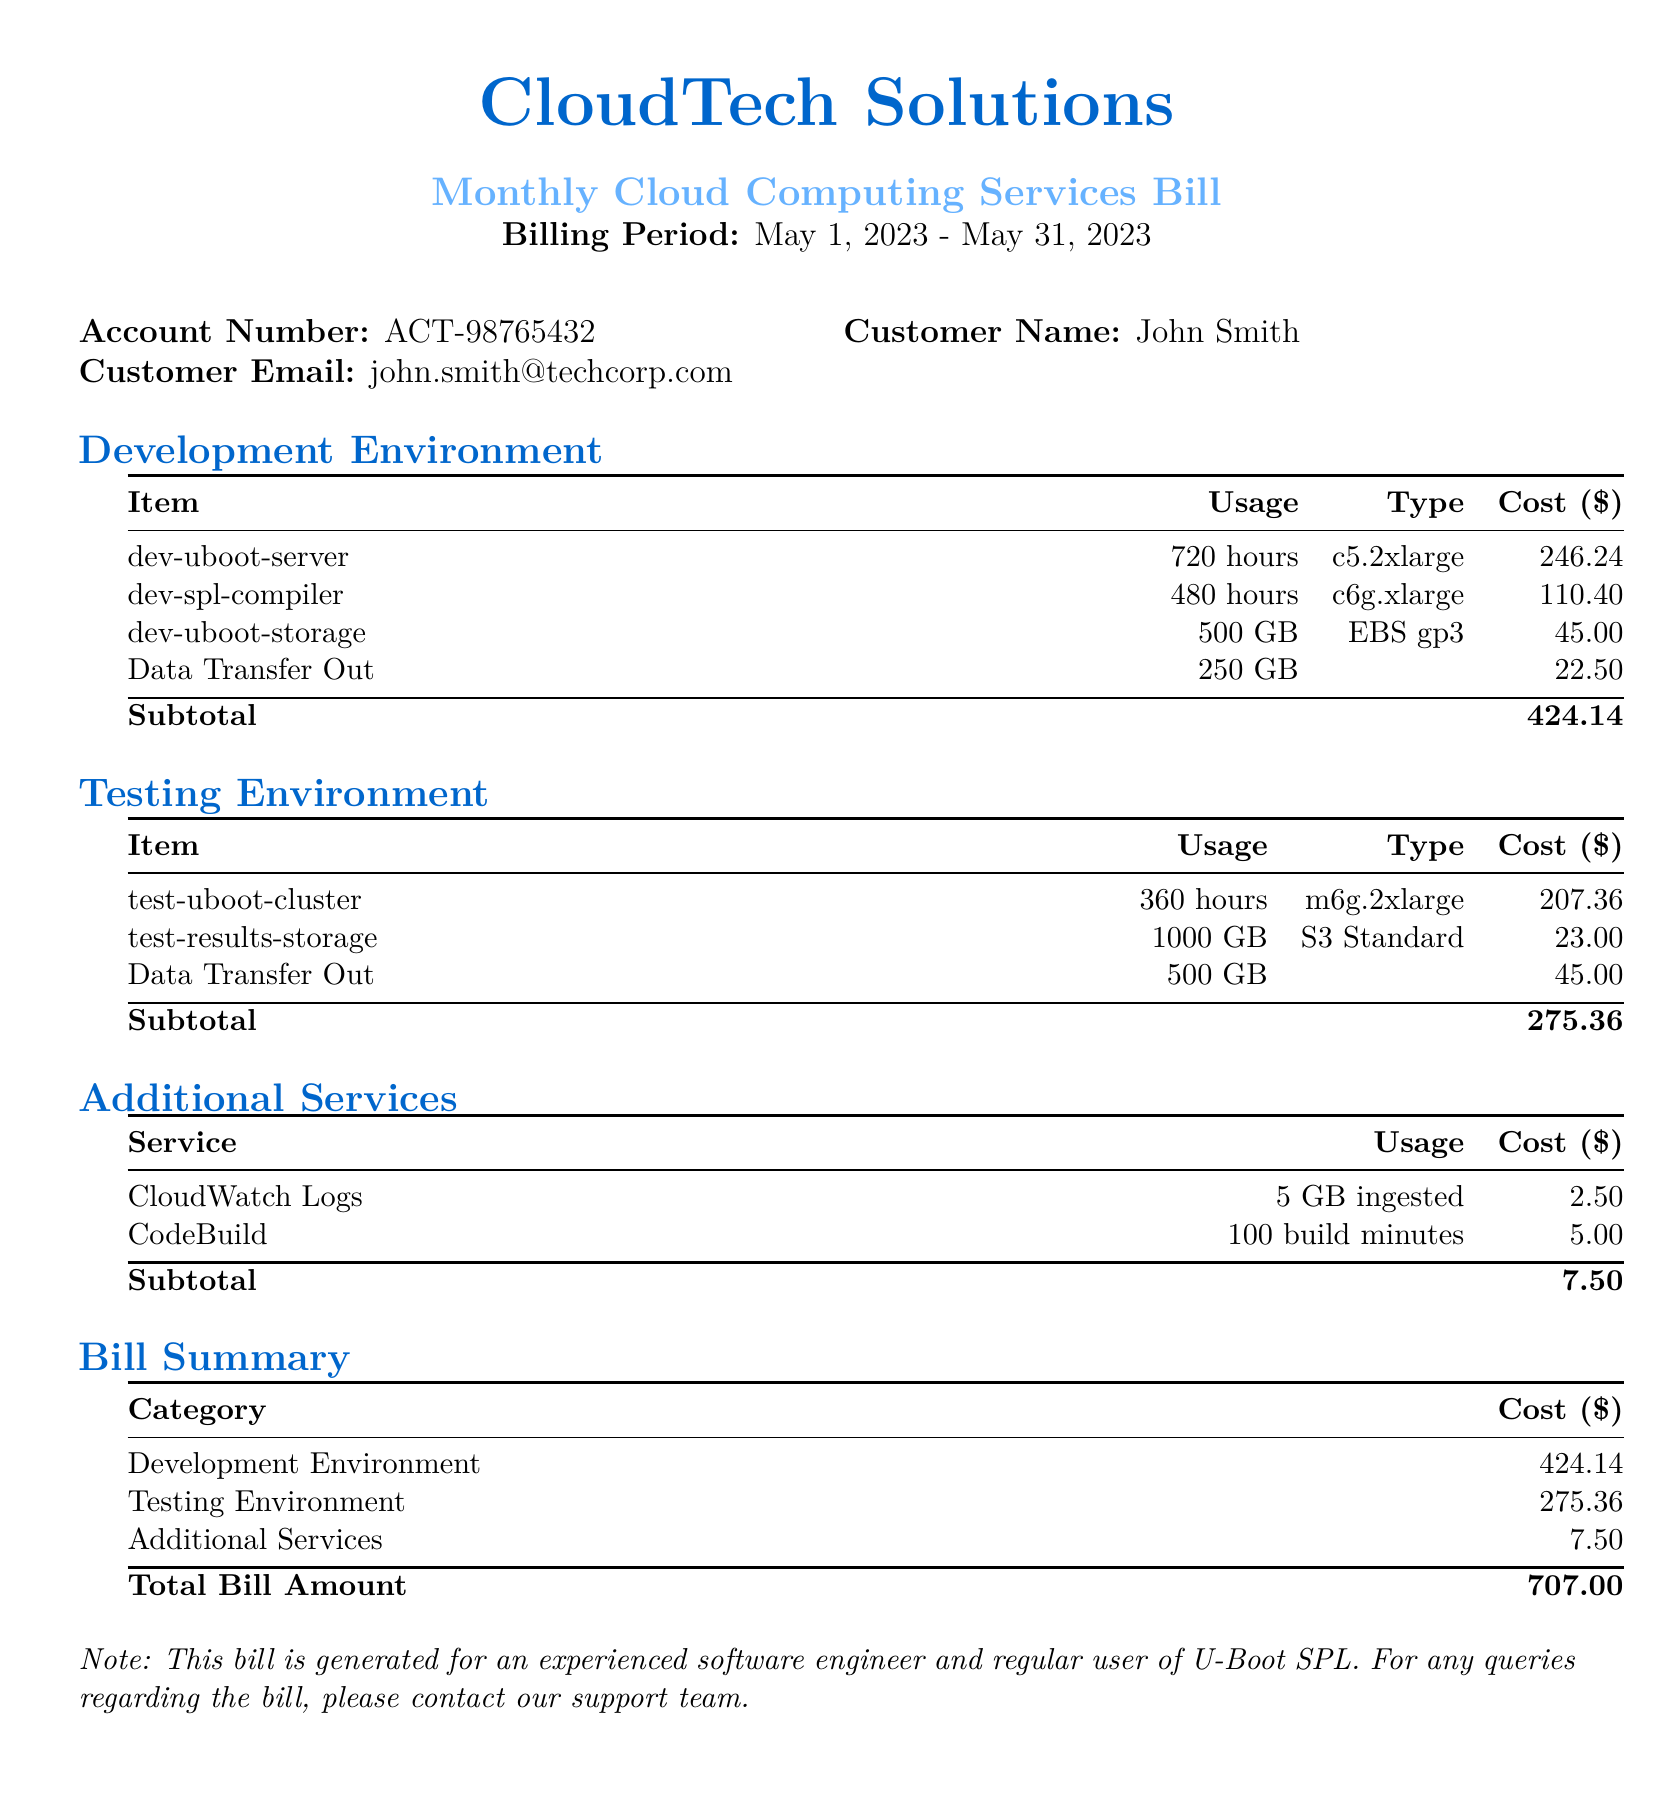What is the billing period? The billing period is indicated at the beginning of the document, which is from May 1, 2023 to May 31, 2023.
Answer: May 1, 2023 - May 31, 2023 Who is the customer? The customer's name is provided in the account information section of the document.
Answer: John Smith What is the total bill amount? The total bill amount is found in the bill summary section and is the sum of all categories.
Answer: 707.00 How many hours of usage does the dev-uboot-server have? The usage for the dev-uboot-server is specified in the development environment section of the document.
Answer: 720 hours What type of service is test-results-storage? The type of the service for test-results-storage is listed in the testing environment section.
Answer: S3 Standard What is the subtotal cost for the Development Environment? The subtotal is found at the end of the development environment section, specifically highlighting costs for that category.
Answer: 424.14 How much does Data Transfer Out cost in the Testing Environment? This specific cost is listed under the testing environment section.
Answer: 45.00 What additional service has a usage of 5 GB ingested? The document describes various additional services, one of which includes a specified usage of 5 GB.
Answer: CloudWatch Logs How much was spent on CodeBuild? The cost related to CodeBuild can be identified in the additional services section of the document.
Answer: 5.00 